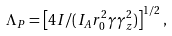Convert formula to latex. <formula><loc_0><loc_0><loc_500><loc_500>\Lambda _ { P } = \left [ 4 I / ( I _ { A } r _ { 0 } ^ { 2 } \gamma \gamma _ { z } ^ { 2 } ) \right ] ^ { 1 / 2 } ,</formula> 